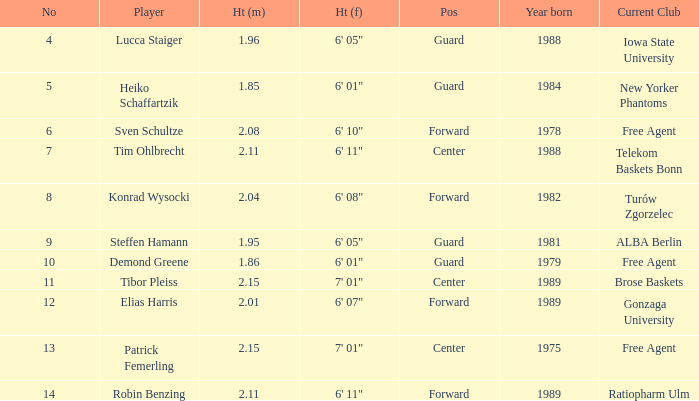11 meters tall. 6' 11". 